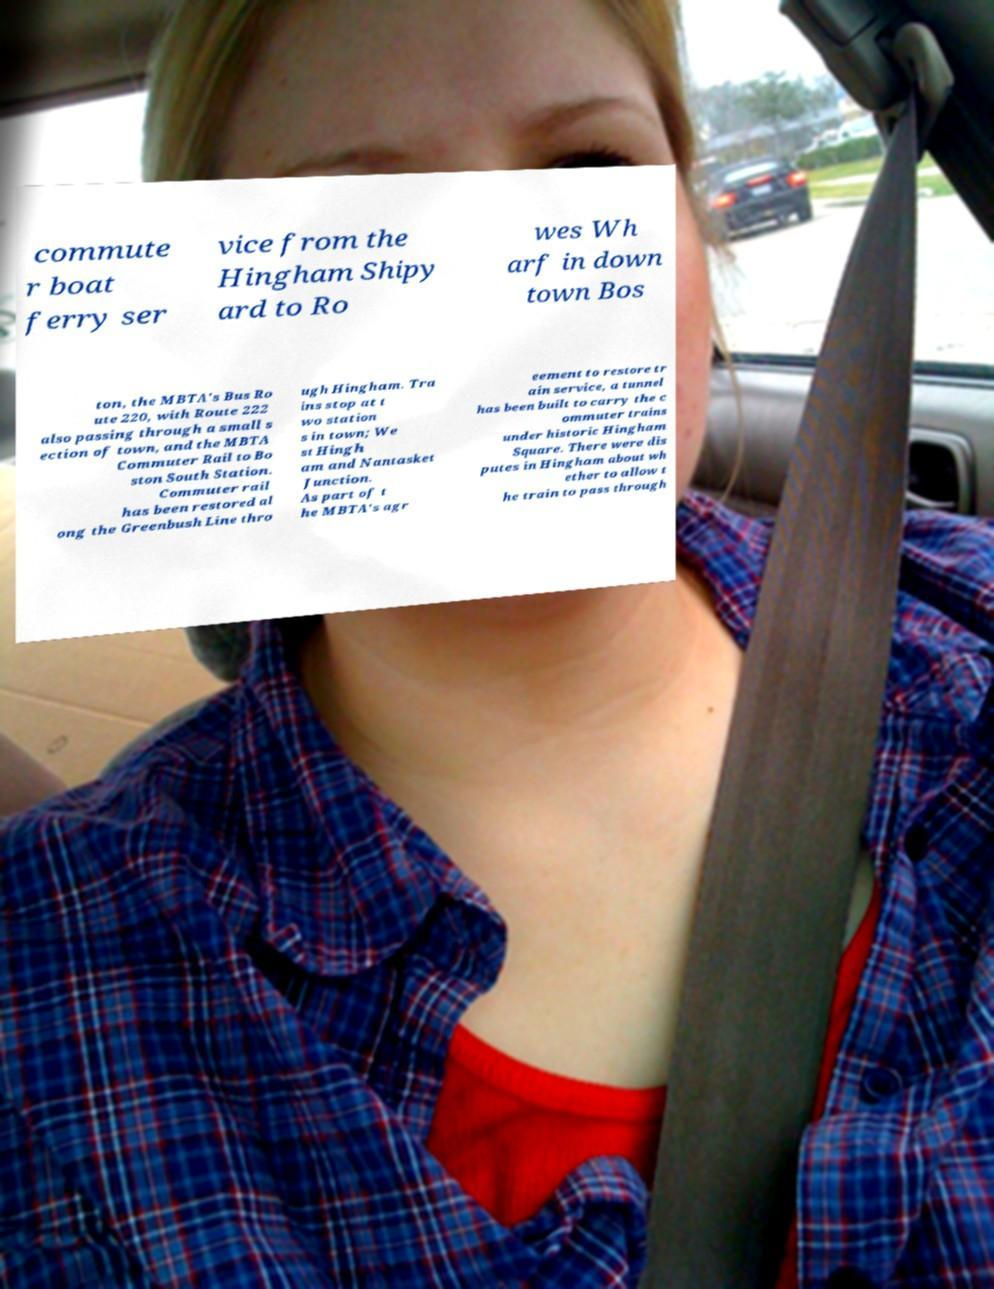I need the written content from this picture converted into text. Can you do that? commute r boat ferry ser vice from the Hingham Shipy ard to Ro wes Wh arf in down town Bos ton, the MBTA's Bus Ro ute 220, with Route 222 also passing through a small s ection of town, and the MBTA Commuter Rail to Bo ston South Station. Commuter rail has been restored al ong the Greenbush Line thro ugh Hingham. Tra ins stop at t wo station s in town; We st Hingh am and Nantasket Junction. As part of t he MBTA's agr eement to restore tr ain service, a tunnel has been built to carry the c ommuter trains under historic Hingham Square. There were dis putes in Hingham about wh ether to allow t he train to pass through 